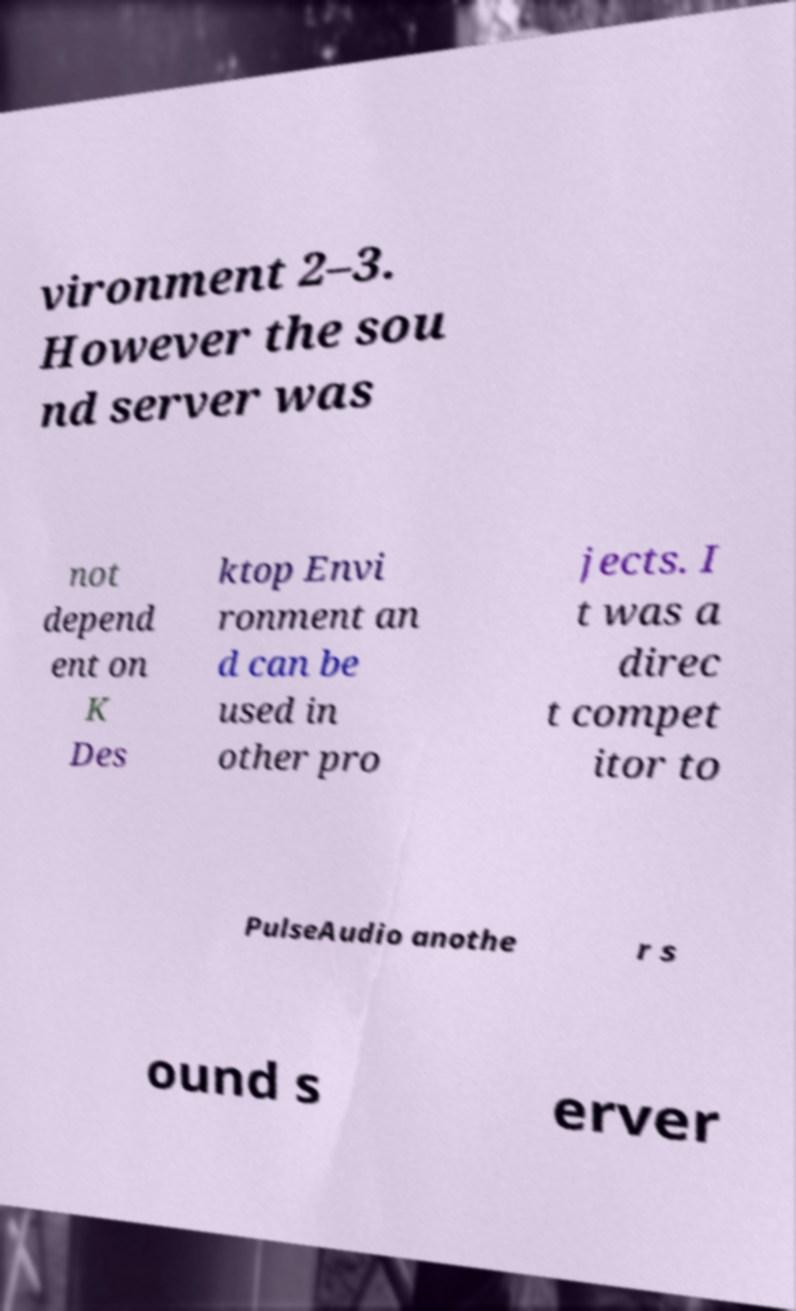Could you assist in decoding the text presented in this image and type it out clearly? vironment 2–3. However the sou nd server was not depend ent on K Des ktop Envi ronment an d can be used in other pro jects. I t was a direc t compet itor to PulseAudio anothe r s ound s erver 